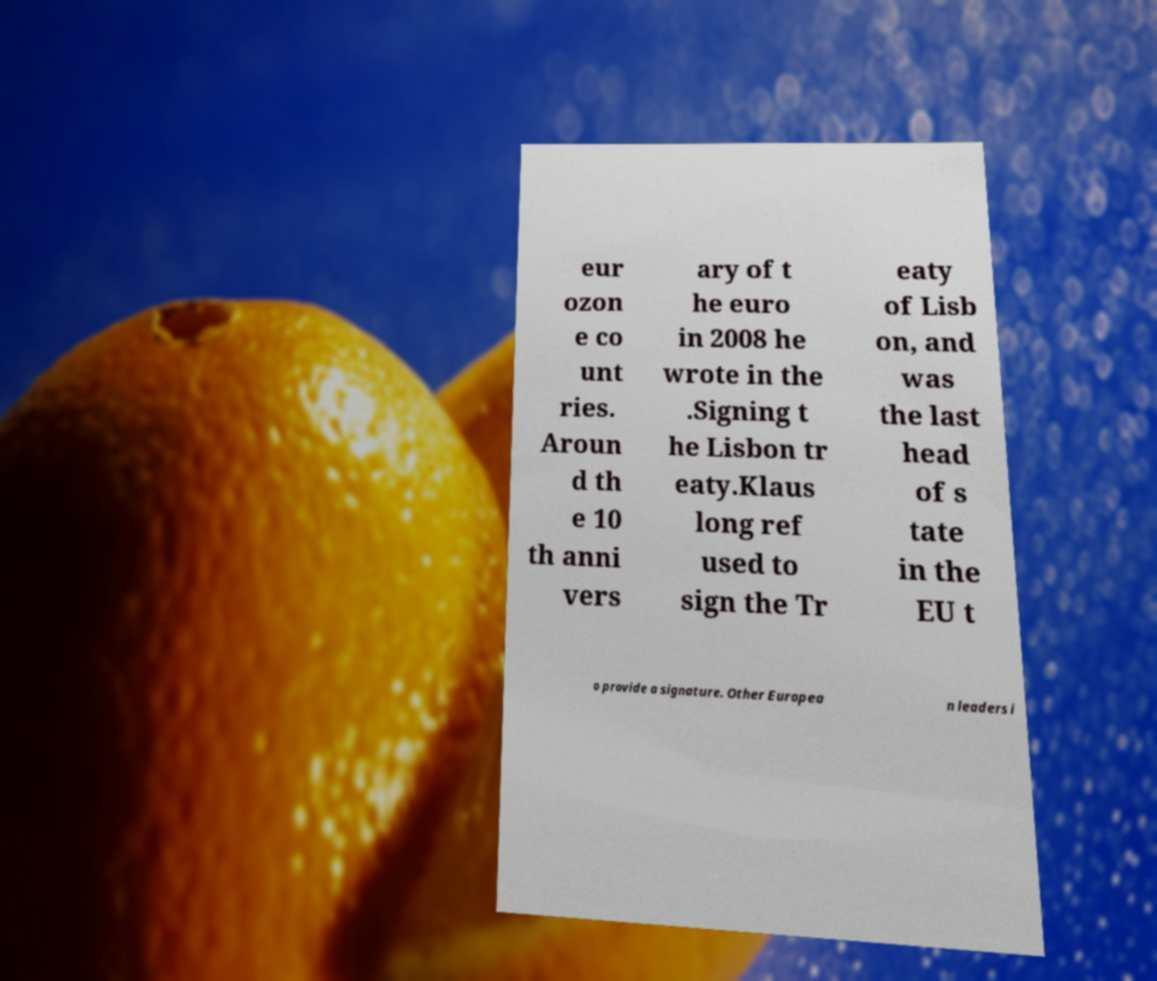Can you read and provide the text displayed in the image?This photo seems to have some interesting text. Can you extract and type it out for me? eur ozon e co unt ries. Aroun d th e 10 th anni vers ary of t he euro in 2008 he wrote in the .Signing t he Lisbon tr eaty.Klaus long ref used to sign the Tr eaty of Lisb on, and was the last head of s tate in the EU t o provide a signature. Other Europea n leaders i 